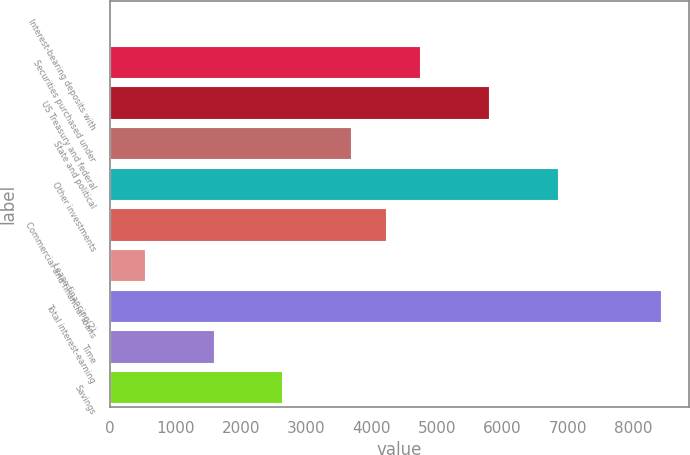<chart> <loc_0><loc_0><loc_500><loc_500><bar_chart><fcel>Interest-bearing deposits with<fcel>Securities purchased under<fcel>US Treasury and federal<fcel>State and political<fcel>Other investments<fcel>Commercial and financial loans<fcel>Lease financing(2)<fcel>Total interest-earning<fcel>Time<fcel>Savings<nl><fcel>1<fcel>4743.1<fcel>5796.9<fcel>3689.3<fcel>6850.7<fcel>4216.2<fcel>527.9<fcel>8431.4<fcel>1581.7<fcel>2635.5<nl></chart> 